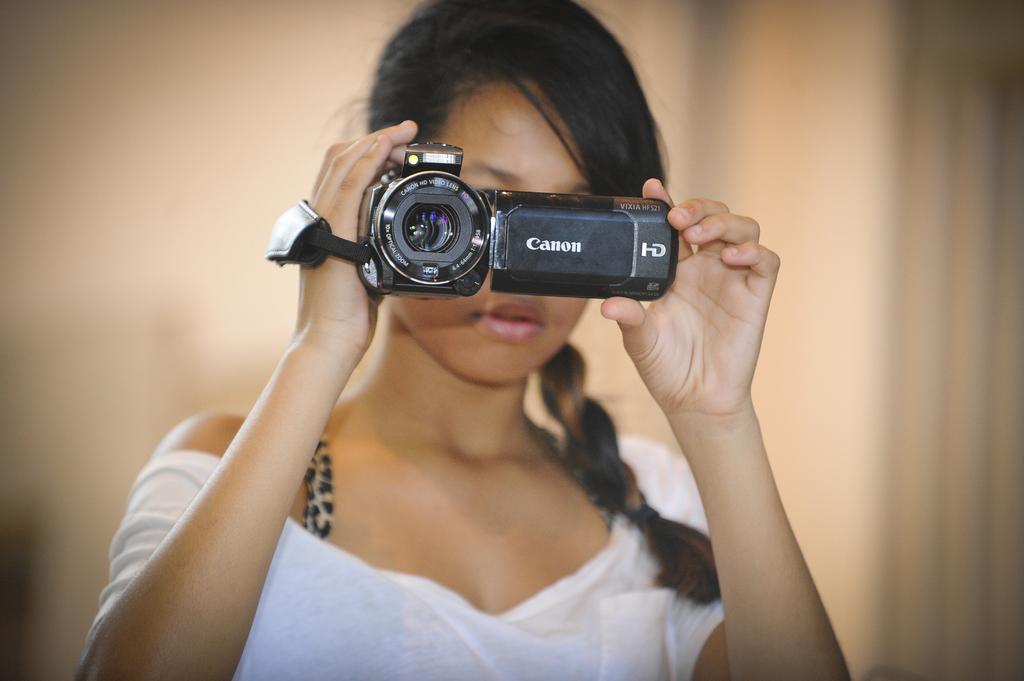How would you summarize this image in a sentence or two? This image consists of a woman standing and holding a camera in her hand. The background is light brown in color. This image is taken inside a house. 